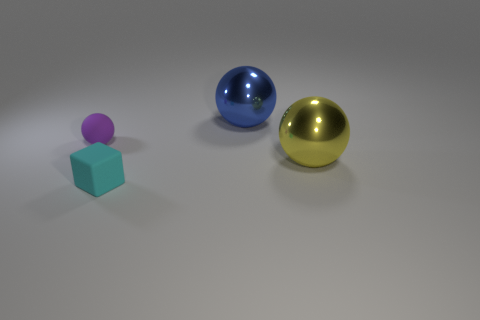Subtract all metal balls. How many balls are left? 1 Add 1 blue shiny things. How many objects exist? 5 Subtract all spheres. How many objects are left? 1 Subtract 0 brown spheres. How many objects are left? 4 Subtract all big blue things. Subtract all shiny objects. How many objects are left? 1 Add 3 yellow metal balls. How many yellow metal balls are left? 4 Add 4 small objects. How many small objects exist? 6 